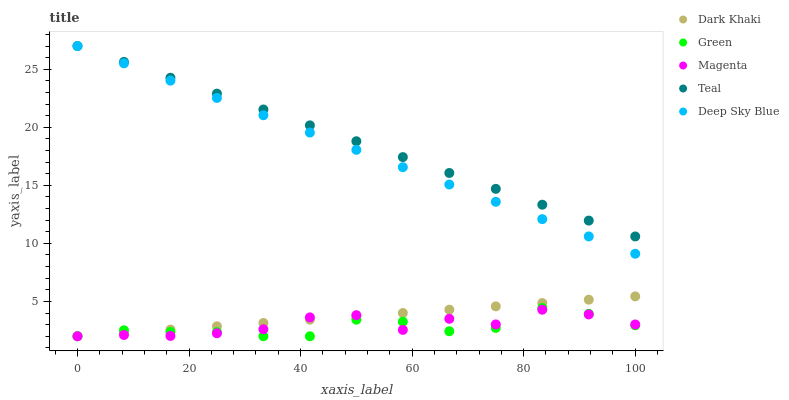Does Green have the minimum area under the curve?
Answer yes or no. Yes. Does Teal have the maximum area under the curve?
Answer yes or no. Yes. Does Magenta have the minimum area under the curve?
Answer yes or no. No. Does Magenta have the maximum area under the curve?
Answer yes or no. No. Is Dark Khaki the smoothest?
Answer yes or no. Yes. Is Magenta the roughest?
Answer yes or no. Yes. Is Green the smoothest?
Answer yes or no. No. Is Green the roughest?
Answer yes or no. No. Does Dark Khaki have the lowest value?
Answer yes or no. Yes. Does Deep Sky Blue have the lowest value?
Answer yes or no. No. Does Teal have the highest value?
Answer yes or no. Yes. Does Green have the highest value?
Answer yes or no. No. Is Magenta less than Deep Sky Blue?
Answer yes or no. Yes. Is Deep Sky Blue greater than Green?
Answer yes or no. Yes. Does Dark Khaki intersect Green?
Answer yes or no. Yes. Is Dark Khaki less than Green?
Answer yes or no. No. Is Dark Khaki greater than Green?
Answer yes or no. No. Does Magenta intersect Deep Sky Blue?
Answer yes or no. No. 